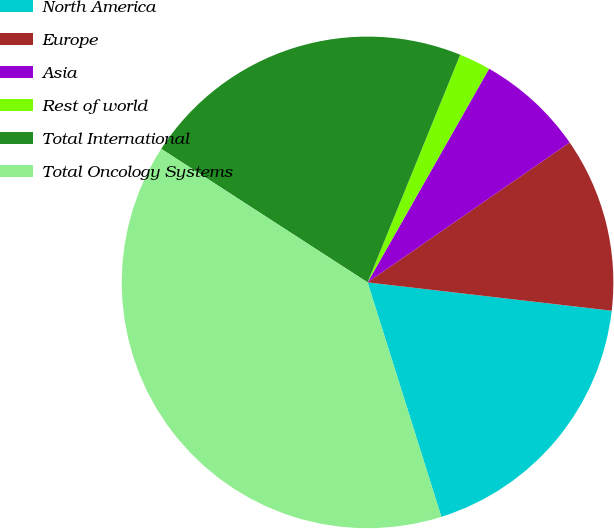Convert chart to OTSL. <chart><loc_0><loc_0><loc_500><loc_500><pie_chart><fcel>North America<fcel>Europe<fcel>Asia<fcel>Rest of world<fcel>Total International<fcel>Total Oncology Systems<nl><fcel>18.31%<fcel>11.48%<fcel>7.13%<fcel>2.08%<fcel>22.01%<fcel>39.0%<nl></chart> 